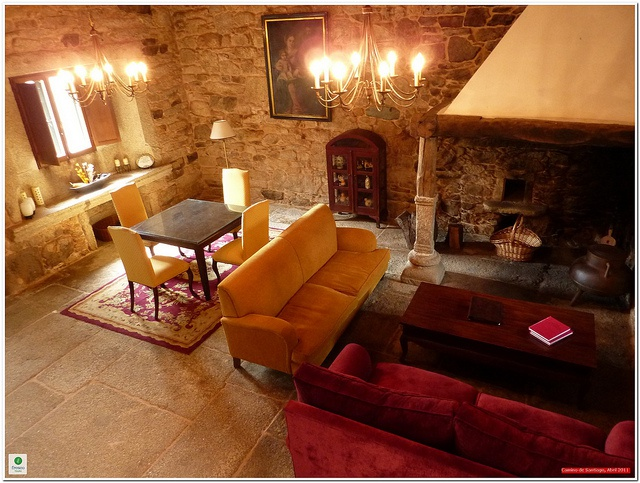Describe the objects in this image and their specific colors. I can see couch in white, maroon, black, and red tones, couch in white, brown, maroon, and orange tones, dining table in white, black, maroon, and brown tones, chair in white, red, black, maroon, and tan tones, and dining table in white, gray, brown, and tan tones in this image. 